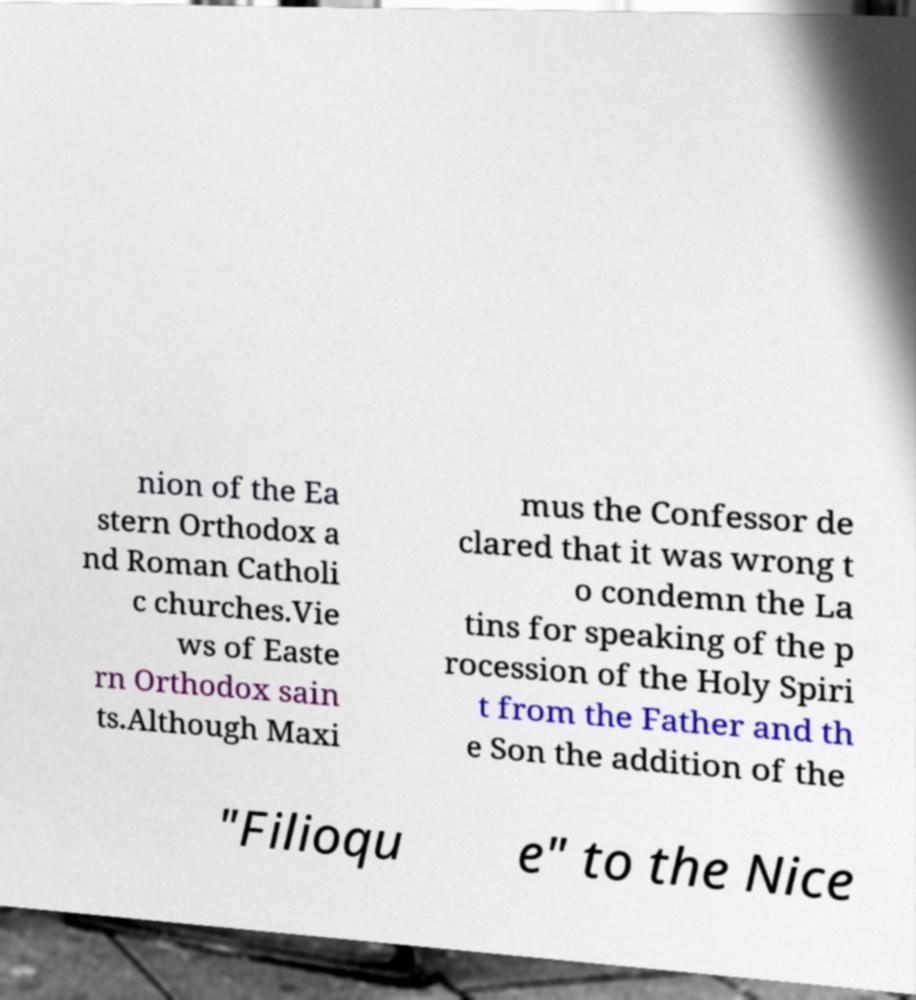What messages or text are displayed in this image? I need them in a readable, typed format. nion of the Ea stern Orthodox a nd Roman Catholi c churches.Vie ws of Easte rn Orthodox sain ts.Although Maxi mus the Confessor de clared that it was wrong t o condemn the La tins for speaking of the p rocession of the Holy Spiri t from the Father and th e Son the addition of the "Filioqu e" to the Nice 